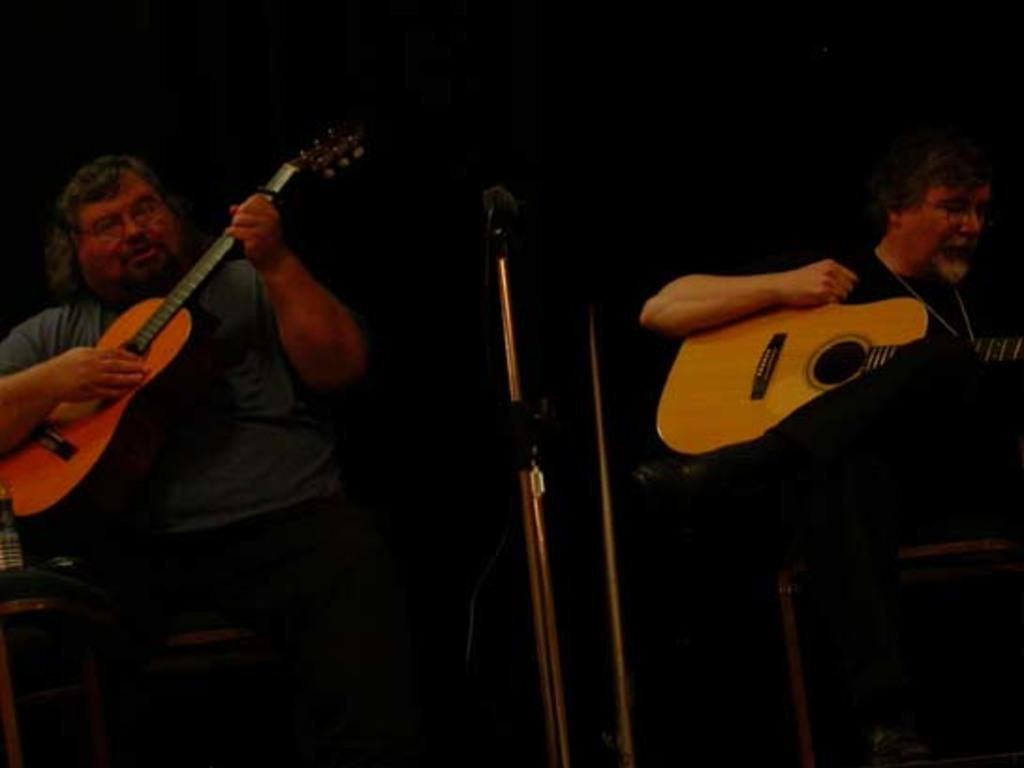How many people are in the image? There are two people in the image. What are the two people doing in the image? The two people are sitting and playing guitar. What object is in front of the two people? There is a microphone in front of them. What type of nerve can be seen connecting the two guitars in the image? There is no nerve connecting the two guitars in the image, as guitars are musical instruments and not living organisms. 